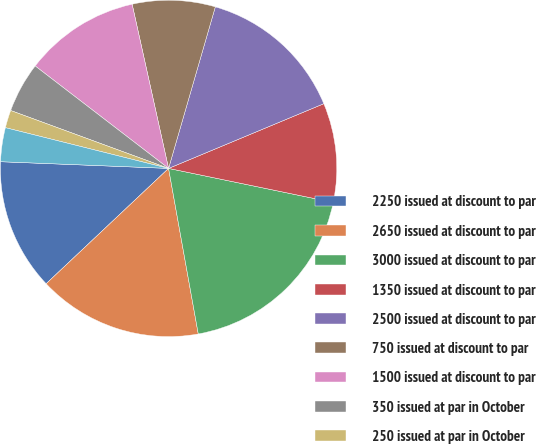Convert chart. <chart><loc_0><loc_0><loc_500><loc_500><pie_chart><fcel>2250 issued at discount to par<fcel>2650 issued at discount to par<fcel>3000 issued at discount to par<fcel>1350 issued at discount to par<fcel>2500 issued at discount to par<fcel>750 issued at discount to par<fcel>1500 issued at discount to par<fcel>350 issued at par in October<fcel>250 issued at par in October<fcel>EDS Senior Notes (1) 300<nl><fcel>12.66%<fcel>15.8%<fcel>18.93%<fcel>9.53%<fcel>14.23%<fcel>7.96%<fcel>11.1%<fcel>4.83%<fcel>1.7%<fcel>3.26%<nl></chart> 